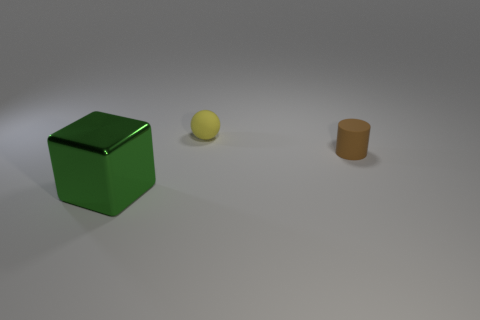Are the tiny thing behind the small brown object and the big green thing made of the same material?
Provide a succinct answer. No. There is a thing that is in front of the small matte ball and behind the large cube; what material is it?
Provide a short and direct response. Rubber. What material is the object in front of the tiny matte thing that is on the right side of the yellow sphere?
Ensure brevity in your answer.  Metal. There is a thing left of the tiny thing that is on the left side of the small matte thing right of the small sphere; how big is it?
Give a very brief answer. Large. What number of green cubes have the same material as the large object?
Keep it short and to the point. 0. What color is the small thing right of the matte object behind the small rubber cylinder?
Your answer should be compact. Brown. What number of objects are matte things or objects to the right of the green metallic block?
Offer a terse response. 2. Are there any large blocks that have the same color as the ball?
Ensure brevity in your answer.  No. What number of gray objects are either tiny cylinders or tiny matte things?
Ensure brevity in your answer.  0. How many other objects are there of the same size as the green cube?
Offer a very short reply. 0. 